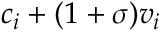<formula> <loc_0><loc_0><loc_500><loc_500>c _ { i } + ( 1 + \sigma ) v _ { i }</formula> 